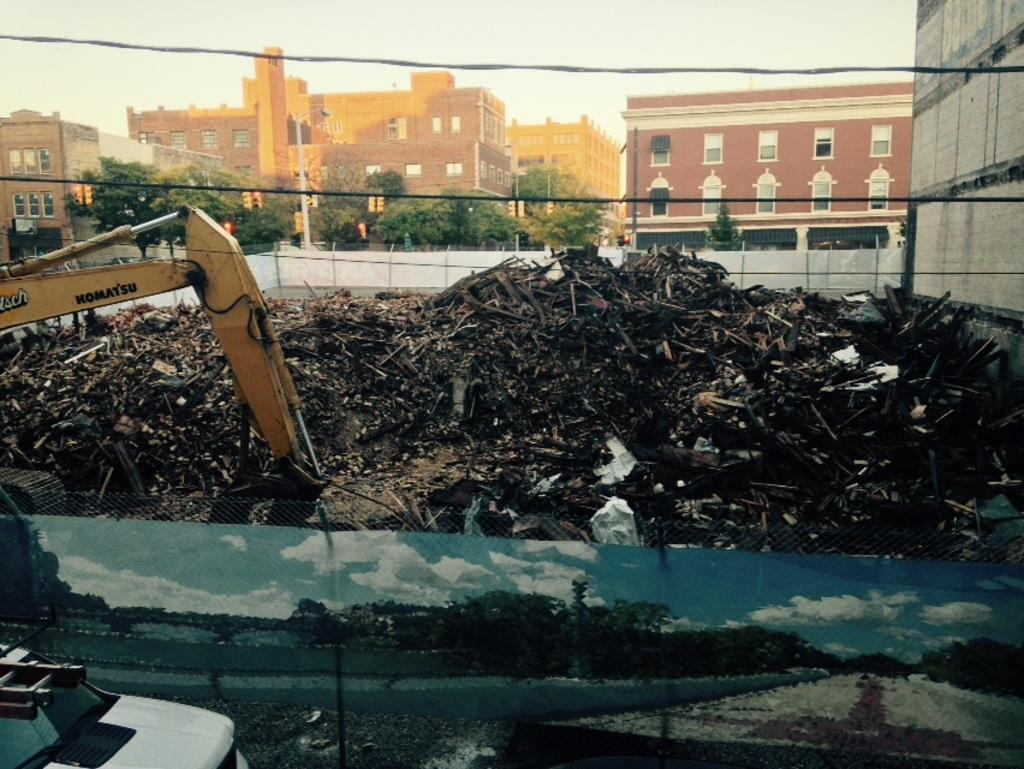What type of artwork is the image? The image is a collage. What mode of transportation can be seen in the image? There is a vehicle in the image. What type of waste is present in the image? Garbage is present in the image. What type of structures are visible in the image? There are buildings in the image. What type of vegetation is visible in the image? Trees are visible in the image. What type of vertical structures are present in the image? Poles are present in the image. What part of the natural environment is visible in the image? The sky is visible in the image. What type of pathway is visible in the image? There is a road in the image. What type of vegetation is visible near the road? Trees are visible near the road. What type of hairstyle does the aunt have in the image? There is no aunt or hair present in the image. What type of injury is visible on the knee in the image? There is no knee or injury present in the image. 